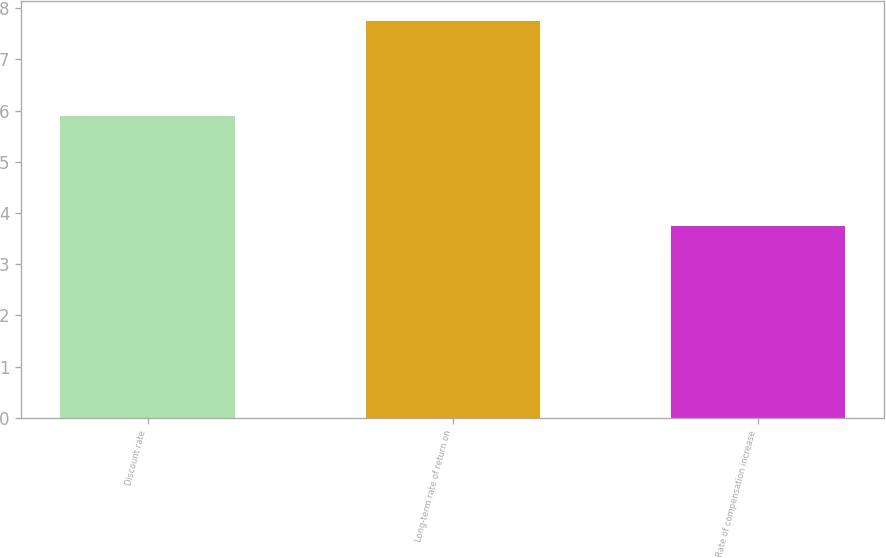Convert chart. <chart><loc_0><loc_0><loc_500><loc_500><bar_chart><fcel>Discount rate<fcel>Long-term rate of return on<fcel>Rate of compensation increase<nl><fcel>5.9<fcel>7.75<fcel>3.75<nl></chart> 